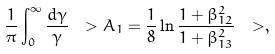<formula> <loc_0><loc_0><loc_500><loc_500>\frac { 1 } { \pi } \int _ { 0 } ^ { \infty } \frac { d \gamma } { \gamma } \ > A _ { 1 } = \frac { 1 } { 8 } \ln \frac { 1 + \beta _ { 1 2 } ^ { 2 } } { 1 + \beta _ { 1 3 } ^ { 2 } } \ > ,</formula> 